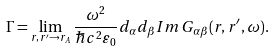<formula> <loc_0><loc_0><loc_500><loc_500>\Gamma = \lim _ { r , r ^ { \prime } \to r _ { A } } \frac { \omega ^ { 2 } } { \hbar { c } ^ { 2 } \varepsilon _ { 0 } } d _ { \alpha } d _ { \beta } I m \, G _ { \alpha \beta } ( r , r ^ { \prime } , \omega ) .</formula> 